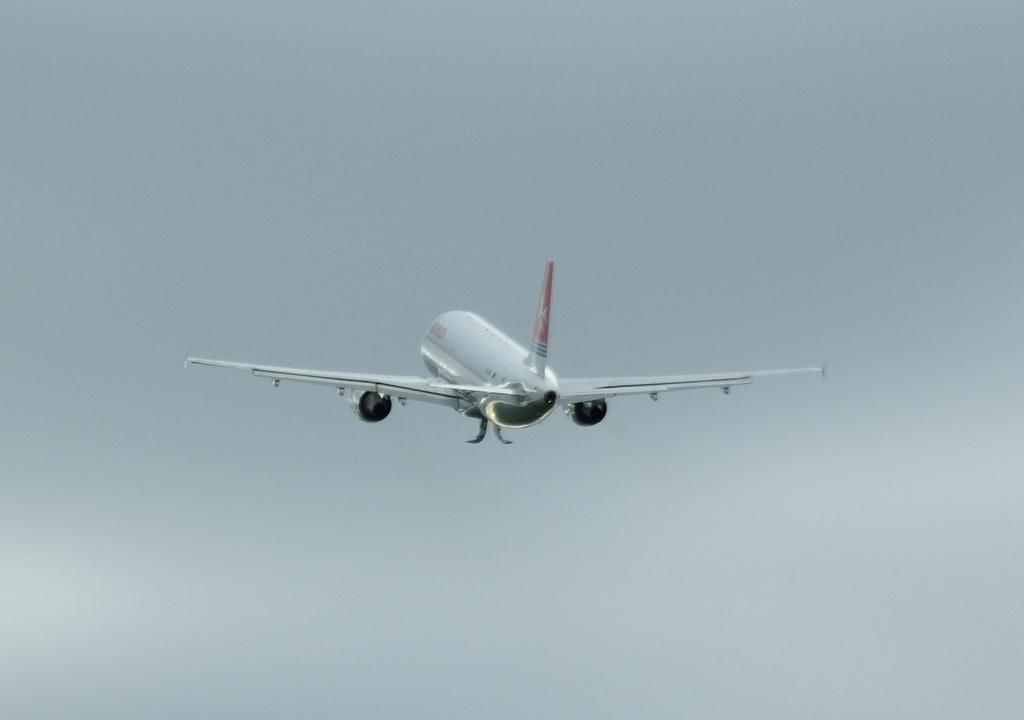What is the main subject of the image? The main subject of the image is an airplane. What is the airplane doing in the image? The airplane is flying in the sky. What can be seen in the sky in the image? There are clouds visible in the image. What type of protest is happening on the airplane in the image? There is no protest happening on the airplane in the image. What is the airplane made of, specifically in terms of metal composition? The facts provided do not give information about the metal composition of the airplane. 